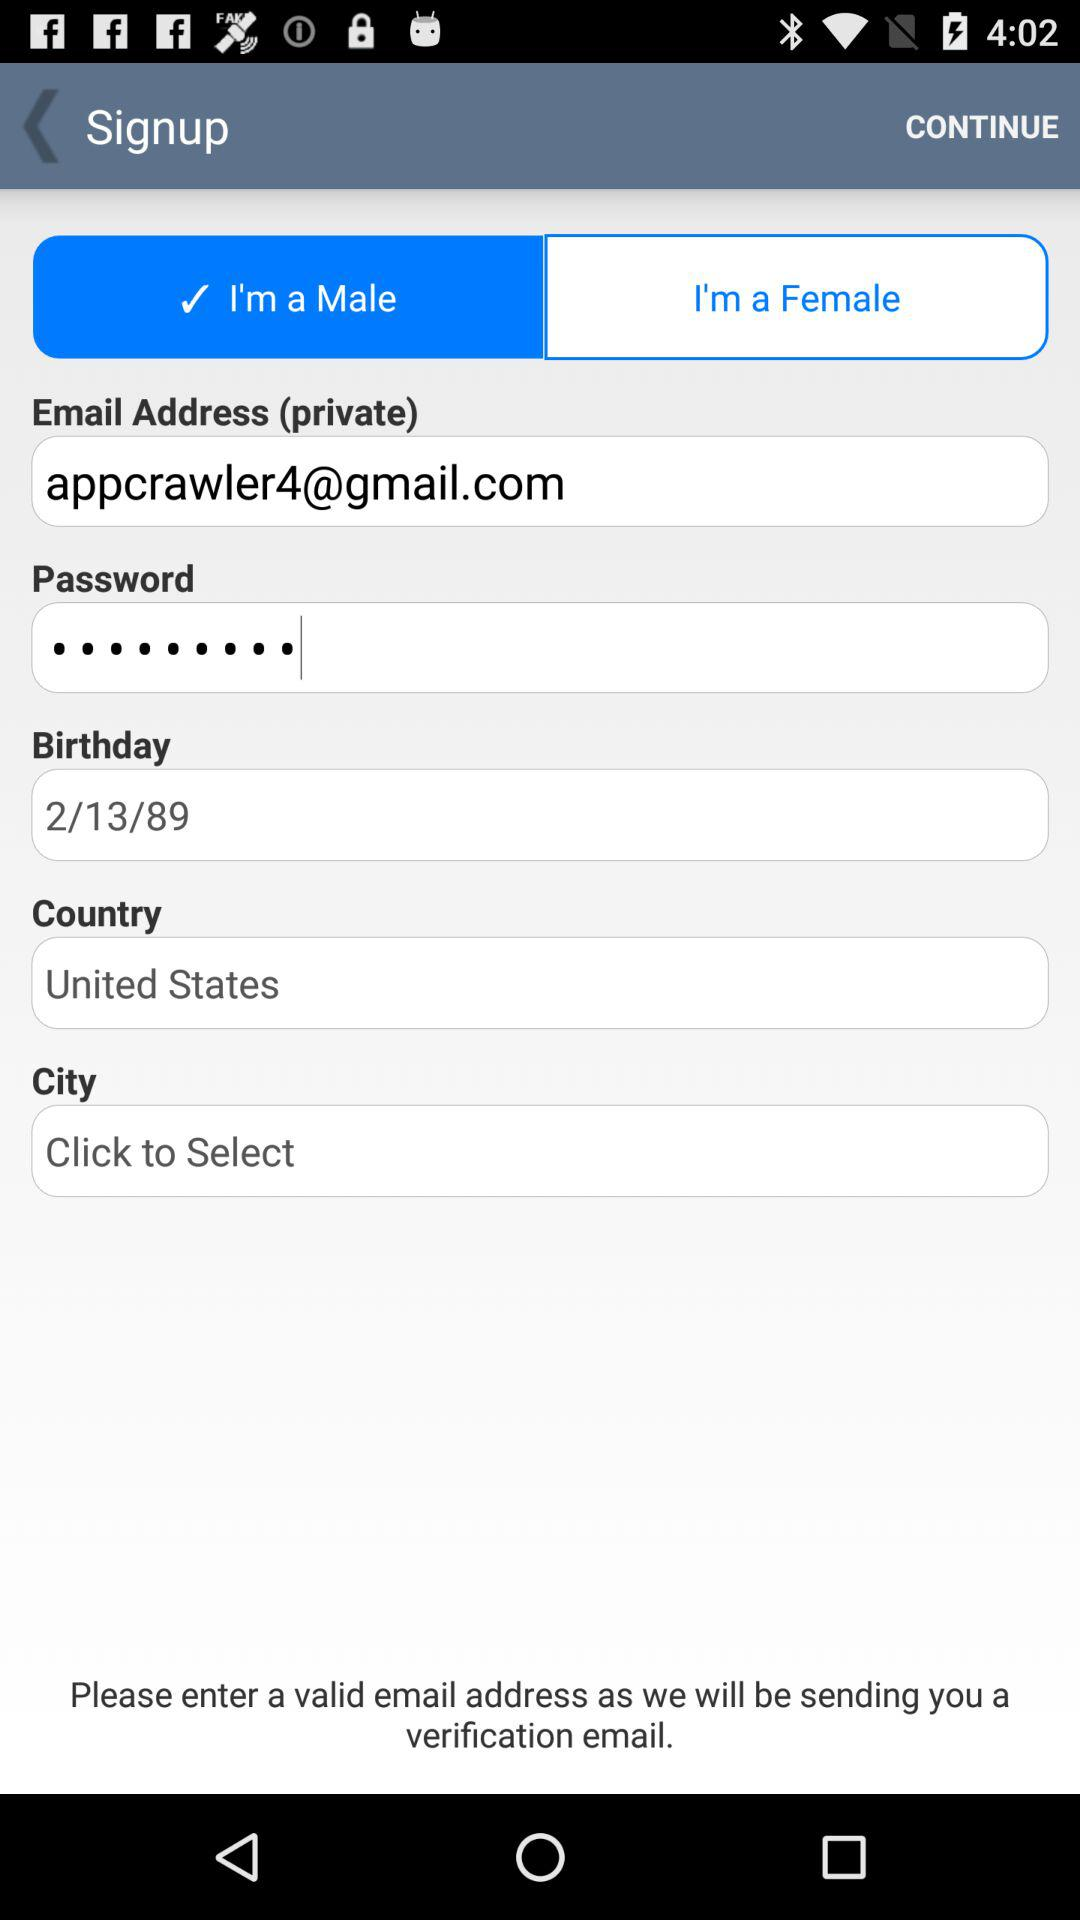What's the selected gender option? The selected gender option is "I'm a Male". 